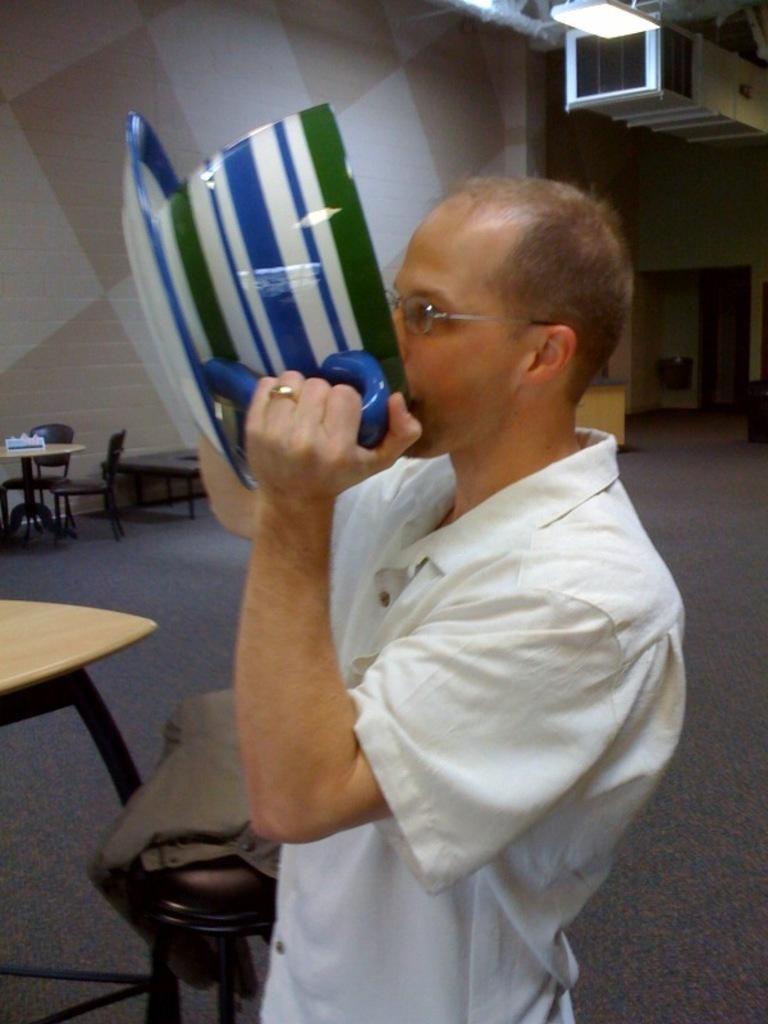Can you describe this image briefly? In the center of the image there is a person standing. On The left side of the image there is a table, stool, chair. In the background there is a air conditioner, light, wall, table and a door. 